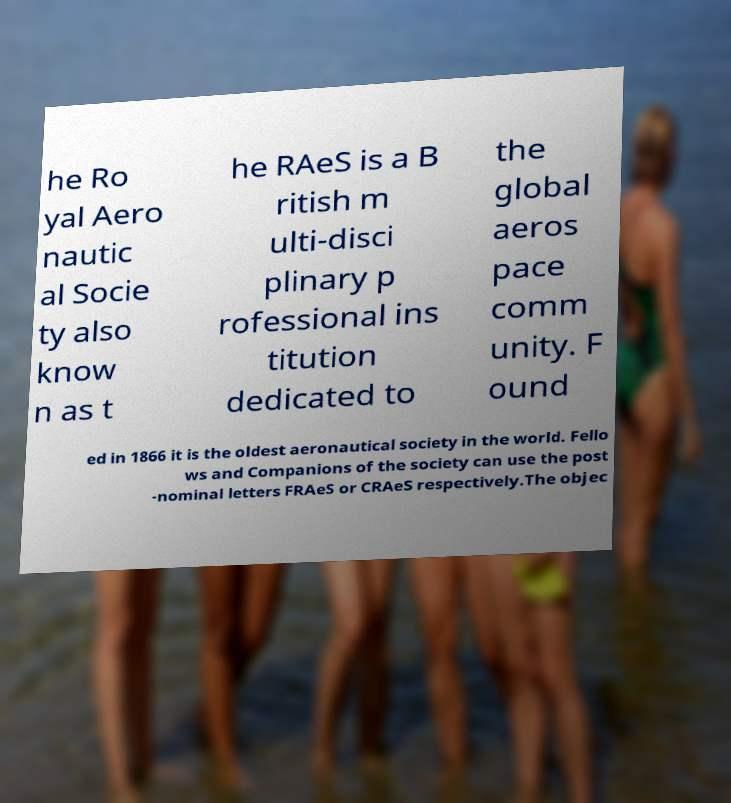Can you read and provide the text displayed in the image?This photo seems to have some interesting text. Can you extract and type it out for me? he Ro yal Aero nautic al Socie ty also know n as t he RAeS is a B ritish m ulti-disci plinary p rofessional ins titution dedicated to the global aeros pace comm unity. F ound ed in 1866 it is the oldest aeronautical society in the world. Fello ws and Companions of the society can use the post -nominal letters FRAeS or CRAeS respectively.The objec 